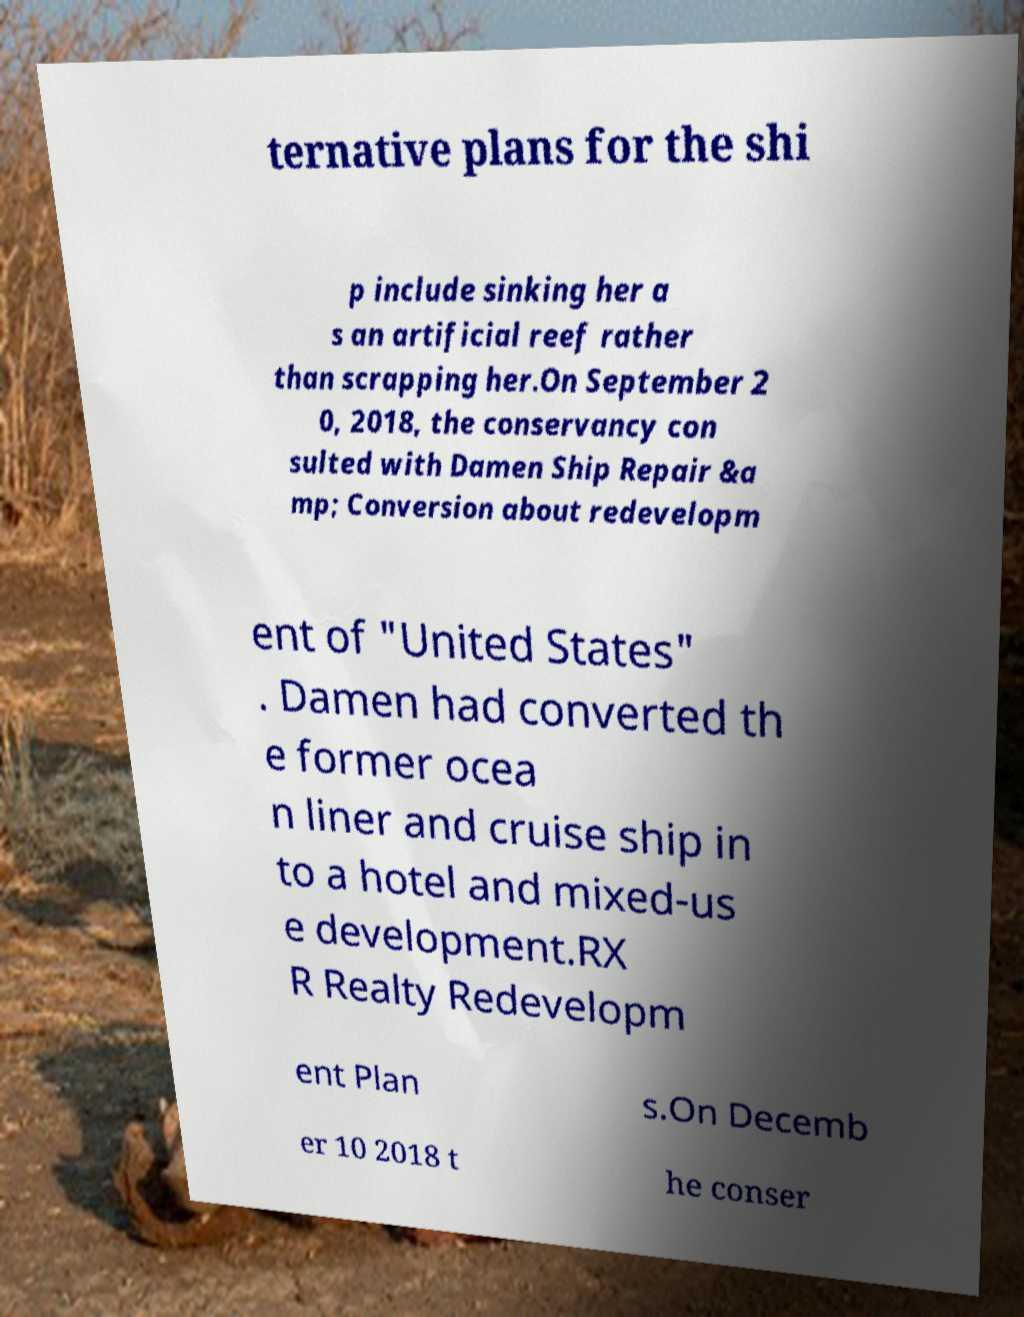Could you extract and type out the text from this image? ternative plans for the shi p include sinking her a s an artificial reef rather than scrapping her.On September 2 0, 2018, the conservancy con sulted with Damen Ship Repair &a mp; Conversion about redevelopm ent of "United States" . Damen had converted th e former ocea n liner and cruise ship in to a hotel and mixed-us e development.RX R Realty Redevelopm ent Plan s.On Decemb er 10 2018 t he conser 